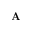<formula> <loc_0><loc_0><loc_500><loc_500>A</formula> 